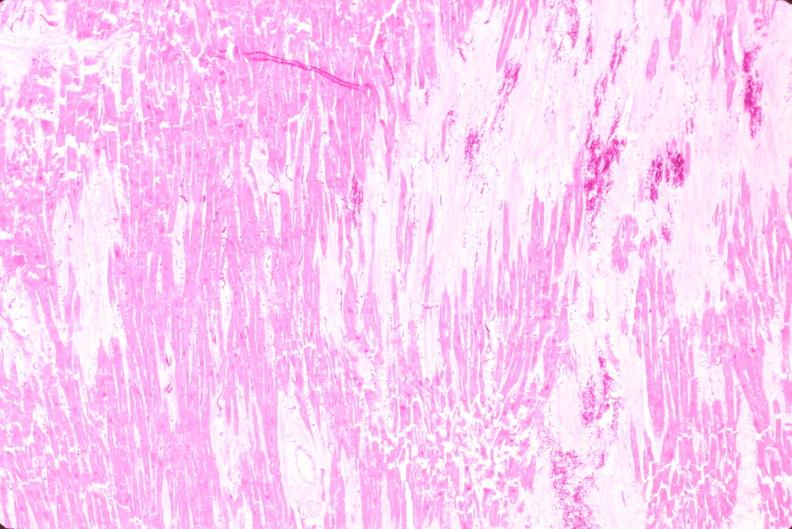what does this image show?
Answer the question using a single word or phrase. Heart 